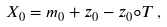<formula> <loc_0><loc_0><loc_500><loc_500>X _ { 0 } = m _ { 0 } + z _ { 0 } - z _ { 0 } \circ T \, ,</formula> 